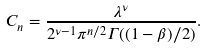Convert formula to latex. <formula><loc_0><loc_0><loc_500><loc_500>C _ { n } = \frac { \lambda ^ { \nu } } { 2 ^ { \nu - 1 } \pi ^ { n / 2 } \Gamma ( ( 1 - \beta ) / 2 ) } .</formula> 